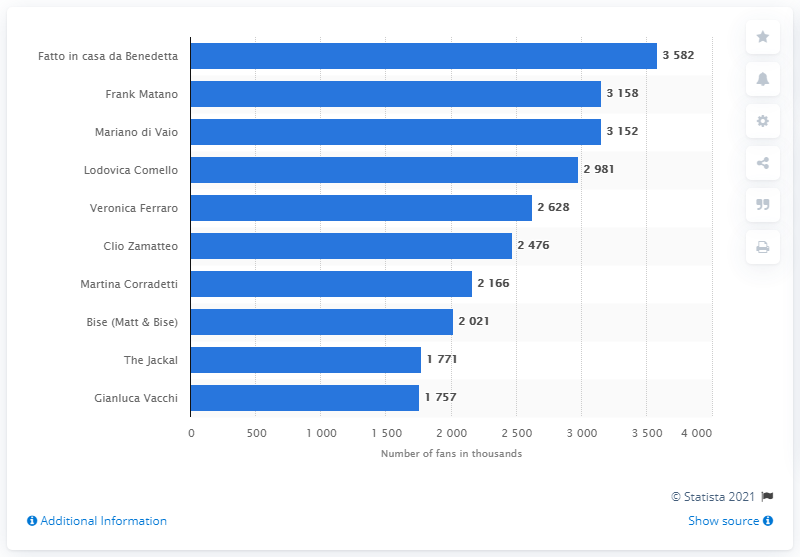Mention a couple of crucial points in this snapshot. Benedetta's homemade food page ranked first with 3.5 million fans. 